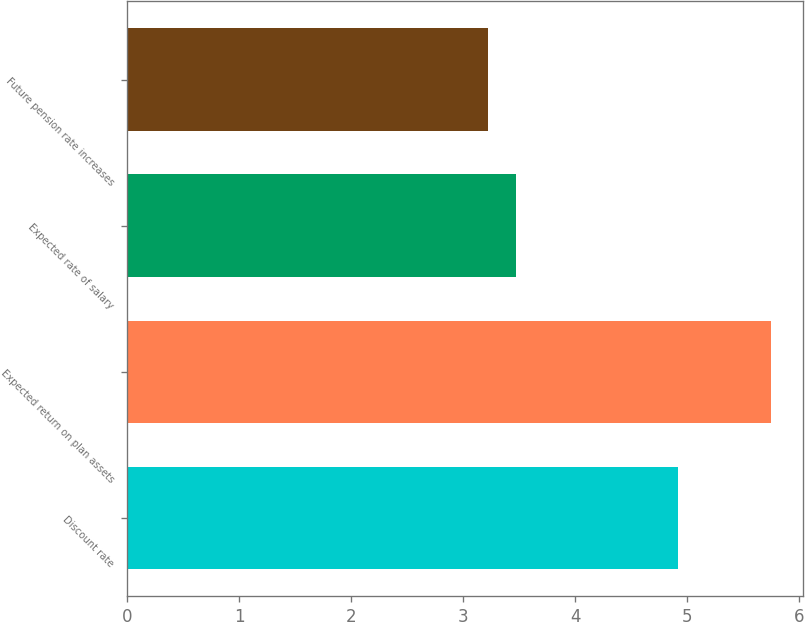Convert chart to OTSL. <chart><loc_0><loc_0><loc_500><loc_500><bar_chart><fcel>Discount rate<fcel>Expected return on plan assets<fcel>Expected rate of salary<fcel>Future pension rate increases<nl><fcel>4.92<fcel>5.75<fcel>3.47<fcel>3.22<nl></chart> 